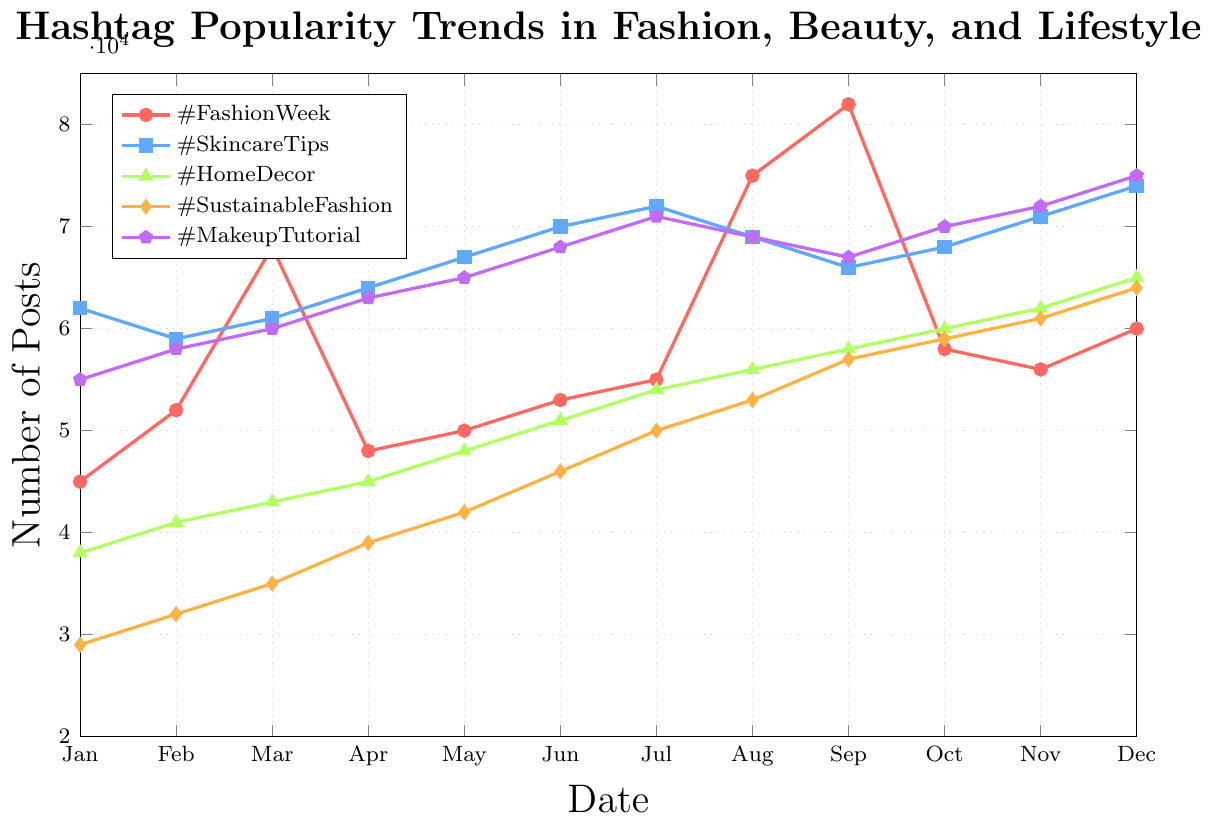What's the highest number of posts for #FashionWeek throughout the year? The highest point on the line representing #FashionWeek needs to be identified. It peaks at 82,000 posts in September.
Answer: 82,000 Which hashtag showed the most consistent growth over the year? We look for a line with a steady upward trend without many dips. #SustainableFashion consistently increases from 29,000 in January to 64,000 in December.
Answer: #SustainableFashion What is the difference in the number of posts for #MakeupTutorial between February and November? Identify the posts in February (58,000) and November (72,000) and calculate the difference: 72,000 - 58,000 = 14,000.
Answer: 14,000 In which month did #HomeDecor surpass 50,000 posts for the first time? Look at the line representing #HomeDecor and find the first point where it exceeds 50,000, which is in June with 51,000 posts.
Answer: June Compare the peak popularity of #SkincareTips and #FashionWeek. Which is higher, and by how much? The peaks need to be identified: #FashionWeek peaks at 82,000 in September, while #SkincareTips peaks at 74,000 in December. The difference is 82,000 - 74,000 = 8,000.
Answer: #FashionWeek by 8,000 What are the overall trends for the hashtags in the first half of the year compared to the second half? Compare January to June and July to December for all hashtags. All hashtags generally increase, but #FashionWeek and #MakeupTutorial show more fluctuation. The second half shows sharper increases, especially for #FashionWeek, #HomeDecor, and #SustainableFashion.
Answer: First half shows growth; second half shows sharper increases Which hashtag had a noticeable drop in popularity in October, and by how much? Identify the hashtag with a noticeable decline between September and October. #FashionWeek drops from 82,000 in September to 58,000 in October. The drop is 82,000 - 58,000 = 24,000.
Answer: #FashionWeek by 24,000 What’s the sum of the number of posts for #SkincareTips and #MakeupTutorial in December? Identify the posts in December for #SkincareTips (74,000) and #MakeupTutorial (75,000) and sum them: 74,000 + 75,000 = 149,000.
Answer: 149,000 What is the average number of posts for #HomeDecor in the last quarter of the year? Calculate the mean for October (60,000), November (62,000), and December (65,000) posts. (60,000 + 62,000 + 65,000) / 3 = 62,333.33.
Answer: 62,333.33 Which hashtag showed a decrease in posts from August to September, and did it recover in October? Check the values from August to September; #SkincareTips decreased from 69,000 to 66,000. In October, it increased to 68,000.
Answer: #SkincareTips, yes 